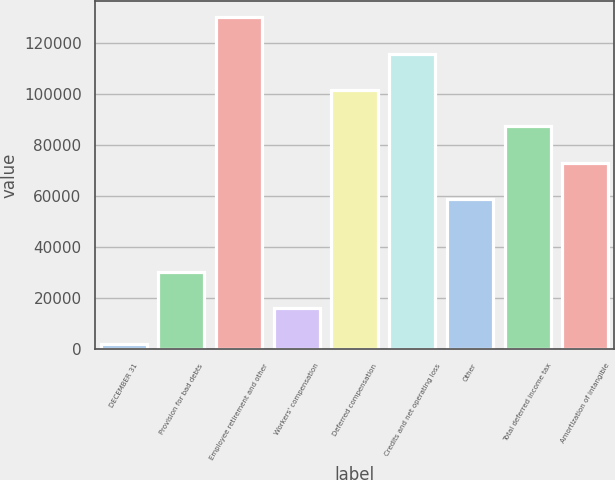Convert chart to OTSL. <chart><loc_0><loc_0><loc_500><loc_500><bar_chart><fcel>DECEMBER 31<fcel>Provision for bad debts<fcel>Employee retirement and other<fcel>Workers' compensation<fcel>Deferred compensation<fcel>Credits and net operating loss<fcel>Other<fcel>Total deferred income tax<fcel>Amortization of intangible<nl><fcel>2008<fcel>30415.6<fcel>129842<fcel>16211.8<fcel>101435<fcel>115638<fcel>58823.2<fcel>87230.8<fcel>73027<nl></chart> 